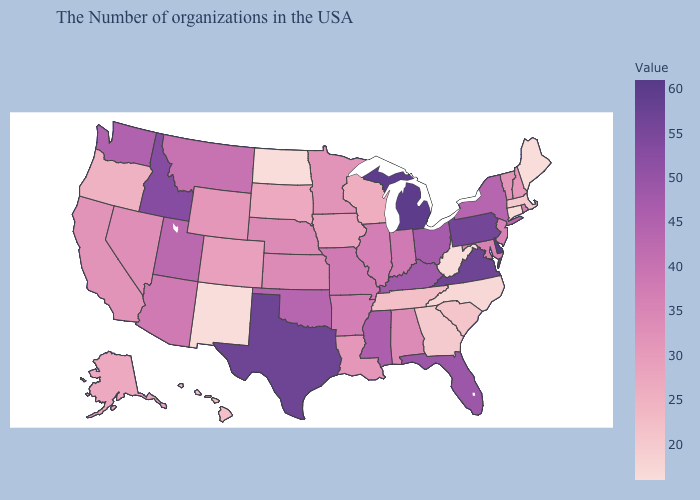Does California have the lowest value in the USA?
Concise answer only. No. Does the map have missing data?
Write a very short answer. No. Which states have the lowest value in the MidWest?
Quick response, please. North Dakota. Among the states that border Nevada , does California have the highest value?
Answer briefly. No. Does New Mexico have the lowest value in the West?
Write a very short answer. Yes. 